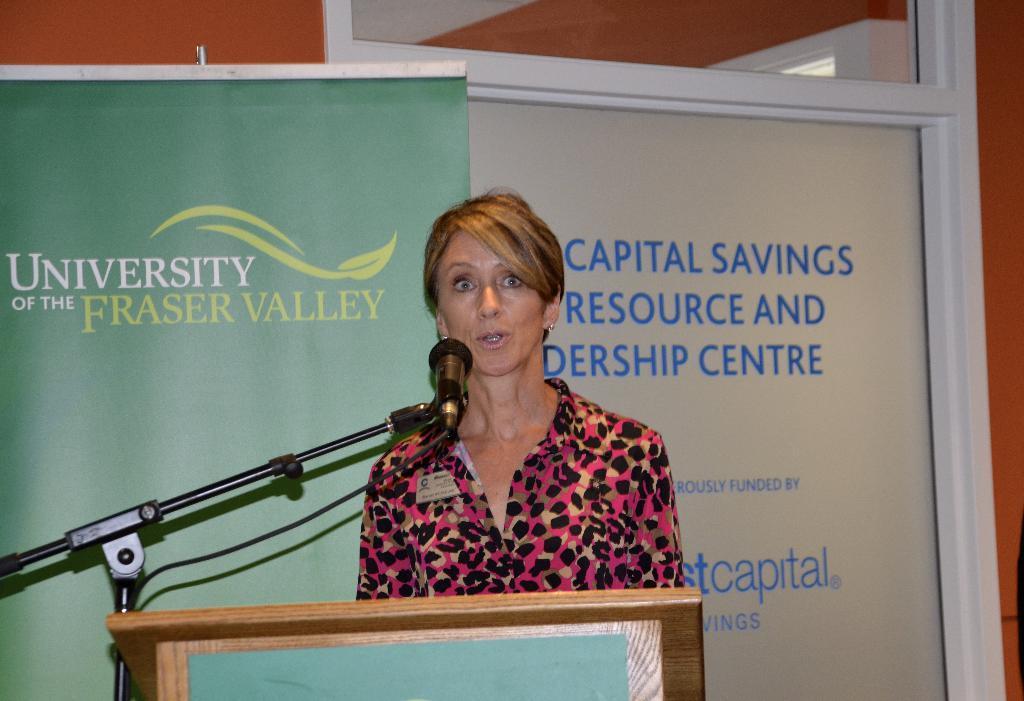What is the lady in the image doing? The lady in the image is standing and talking. What object is in front of the lady? A microphone is present before the lady. What structure can be seen at the bottom of the image? There is a podium at the bottom of the image. What can be seen in the background of the image? There is a banner and a wall visible in the background of the image. What type of linen is draped over the podium in the image? There is no linen draped over the podium in the image; it is not mentioned in the provided facts. How many ants can be seen crawling on the banner in the image? There are no ants present in the image; they are not mentioned in the provided facts. 